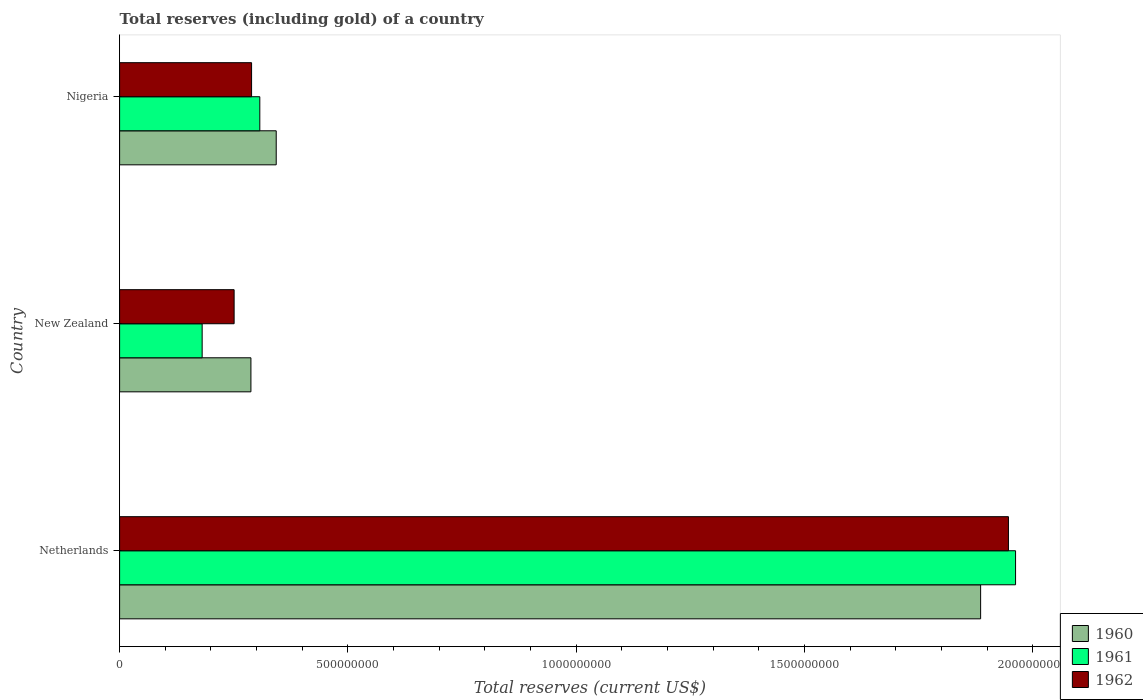How many different coloured bars are there?
Offer a terse response. 3. Are the number of bars per tick equal to the number of legend labels?
Keep it short and to the point. Yes. How many bars are there on the 3rd tick from the top?
Provide a short and direct response. 3. How many bars are there on the 3rd tick from the bottom?
Your answer should be very brief. 3. What is the label of the 1st group of bars from the top?
Offer a very short reply. Nigeria. What is the total reserves (including gold) in 1962 in Netherlands?
Offer a terse response. 1.95e+09. Across all countries, what is the maximum total reserves (including gold) in 1961?
Keep it short and to the point. 1.96e+09. Across all countries, what is the minimum total reserves (including gold) in 1962?
Give a very brief answer. 2.51e+08. In which country was the total reserves (including gold) in 1961 minimum?
Offer a very short reply. New Zealand. What is the total total reserves (including gold) in 1962 in the graph?
Provide a succinct answer. 2.49e+09. What is the difference between the total reserves (including gold) in 1960 in New Zealand and that in Nigeria?
Provide a succinct answer. -5.54e+07. What is the difference between the total reserves (including gold) in 1962 in Netherlands and the total reserves (including gold) in 1961 in Nigeria?
Provide a succinct answer. 1.64e+09. What is the average total reserves (including gold) in 1961 per country?
Your response must be concise. 8.17e+08. What is the difference between the total reserves (including gold) in 1960 and total reserves (including gold) in 1962 in Netherlands?
Provide a short and direct response. -6.09e+07. In how many countries, is the total reserves (including gold) in 1960 greater than 1500000000 US$?
Offer a terse response. 1. What is the ratio of the total reserves (including gold) in 1960 in New Zealand to that in Nigeria?
Your answer should be very brief. 0.84. Is the total reserves (including gold) in 1961 in New Zealand less than that in Nigeria?
Your answer should be compact. Yes. What is the difference between the highest and the second highest total reserves (including gold) in 1960?
Offer a very short reply. 1.54e+09. What is the difference between the highest and the lowest total reserves (including gold) in 1960?
Offer a terse response. 1.60e+09. In how many countries, is the total reserves (including gold) in 1960 greater than the average total reserves (including gold) in 1960 taken over all countries?
Offer a terse response. 1. Is the sum of the total reserves (including gold) in 1962 in Netherlands and New Zealand greater than the maximum total reserves (including gold) in 1961 across all countries?
Your answer should be compact. Yes. What does the 3rd bar from the top in Nigeria represents?
Keep it short and to the point. 1960. What does the 2nd bar from the bottom in New Zealand represents?
Keep it short and to the point. 1961. Is it the case that in every country, the sum of the total reserves (including gold) in 1961 and total reserves (including gold) in 1960 is greater than the total reserves (including gold) in 1962?
Ensure brevity in your answer.  Yes. How many bars are there?
Provide a short and direct response. 9. Does the graph contain grids?
Give a very brief answer. No. How are the legend labels stacked?
Provide a short and direct response. Vertical. What is the title of the graph?
Give a very brief answer. Total reserves (including gold) of a country. What is the label or title of the X-axis?
Offer a terse response. Total reserves (current US$). What is the label or title of the Y-axis?
Provide a short and direct response. Country. What is the Total reserves (current US$) of 1960 in Netherlands?
Offer a terse response. 1.89e+09. What is the Total reserves (current US$) in 1961 in Netherlands?
Your answer should be very brief. 1.96e+09. What is the Total reserves (current US$) of 1962 in Netherlands?
Give a very brief answer. 1.95e+09. What is the Total reserves (current US$) in 1960 in New Zealand?
Your answer should be compact. 2.88e+08. What is the Total reserves (current US$) of 1961 in New Zealand?
Your response must be concise. 1.81e+08. What is the Total reserves (current US$) of 1962 in New Zealand?
Your response must be concise. 2.51e+08. What is the Total reserves (current US$) of 1960 in Nigeria?
Offer a terse response. 3.43e+08. What is the Total reserves (current US$) of 1961 in Nigeria?
Give a very brief answer. 3.07e+08. What is the Total reserves (current US$) in 1962 in Nigeria?
Give a very brief answer. 2.89e+08. Across all countries, what is the maximum Total reserves (current US$) of 1960?
Your answer should be very brief. 1.89e+09. Across all countries, what is the maximum Total reserves (current US$) of 1961?
Your response must be concise. 1.96e+09. Across all countries, what is the maximum Total reserves (current US$) in 1962?
Your answer should be compact. 1.95e+09. Across all countries, what is the minimum Total reserves (current US$) of 1960?
Your response must be concise. 2.88e+08. Across all countries, what is the minimum Total reserves (current US$) of 1961?
Give a very brief answer. 1.81e+08. Across all countries, what is the minimum Total reserves (current US$) in 1962?
Make the answer very short. 2.51e+08. What is the total Total reserves (current US$) in 1960 in the graph?
Provide a succinct answer. 2.52e+09. What is the total Total reserves (current US$) in 1961 in the graph?
Offer a terse response. 2.45e+09. What is the total Total reserves (current US$) of 1962 in the graph?
Keep it short and to the point. 2.49e+09. What is the difference between the Total reserves (current US$) in 1960 in Netherlands and that in New Zealand?
Provide a short and direct response. 1.60e+09. What is the difference between the Total reserves (current US$) of 1961 in Netherlands and that in New Zealand?
Give a very brief answer. 1.78e+09. What is the difference between the Total reserves (current US$) of 1962 in Netherlands and that in New Zealand?
Offer a terse response. 1.70e+09. What is the difference between the Total reserves (current US$) in 1960 in Netherlands and that in Nigeria?
Your response must be concise. 1.54e+09. What is the difference between the Total reserves (current US$) of 1961 in Netherlands and that in Nigeria?
Your response must be concise. 1.66e+09. What is the difference between the Total reserves (current US$) in 1962 in Netherlands and that in Nigeria?
Provide a succinct answer. 1.66e+09. What is the difference between the Total reserves (current US$) in 1960 in New Zealand and that in Nigeria?
Your answer should be very brief. -5.54e+07. What is the difference between the Total reserves (current US$) in 1961 in New Zealand and that in Nigeria?
Ensure brevity in your answer.  -1.26e+08. What is the difference between the Total reserves (current US$) in 1962 in New Zealand and that in Nigeria?
Give a very brief answer. -3.82e+07. What is the difference between the Total reserves (current US$) in 1960 in Netherlands and the Total reserves (current US$) in 1961 in New Zealand?
Keep it short and to the point. 1.70e+09. What is the difference between the Total reserves (current US$) in 1960 in Netherlands and the Total reserves (current US$) in 1962 in New Zealand?
Provide a succinct answer. 1.63e+09. What is the difference between the Total reserves (current US$) in 1961 in Netherlands and the Total reserves (current US$) in 1962 in New Zealand?
Offer a terse response. 1.71e+09. What is the difference between the Total reserves (current US$) in 1960 in Netherlands and the Total reserves (current US$) in 1961 in Nigeria?
Your answer should be compact. 1.58e+09. What is the difference between the Total reserves (current US$) in 1960 in Netherlands and the Total reserves (current US$) in 1962 in Nigeria?
Your answer should be compact. 1.60e+09. What is the difference between the Total reserves (current US$) in 1961 in Netherlands and the Total reserves (current US$) in 1962 in Nigeria?
Provide a short and direct response. 1.67e+09. What is the difference between the Total reserves (current US$) in 1960 in New Zealand and the Total reserves (current US$) in 1961 in Nigeria?
Provide a short and direct response. -1.95e+07. What is the difference between the Total reserves (current US$) in 1960 in New Zealand and the Total reserves (current US$) in 1962 in Nigeria?
Your response must be concise. -1.43e+06. What is the difference between the Total reserves (current US$) in 1961 in New Zealand and the Total reserves (current US$) in 1962 in Nigeria?
Your answer should be compact. -1.08e+08. What is the average Total reserves (current US$) in 1960 per country?
Keep it short and to the point. 8.39e+08. What is the average Total reserves (current US$) in 1961 per country?
Your answer should be very brief. 8.17e+08. What is the average Total reserves (current US$) in 1962 per country?
Keep it short and to the point. 8.29e+08. What is the difference between the Total reserves (current US$) in 1960 and Total reserves (current US$) in 1961 in Netherlands?
Provide a short and direct response. -7.65e+07. What is the difference between the Total reserves (current US$) in 1960 and Total reserves (current US$) in 1962 in Netherlands?
Keep it short and to the point. -6.09e+07. What is the difference between the Total reserves (current US$) in 1961 and Total reserves (current US$) in 1962 in Netherlands?
Your answer should be compact. 1.56e+07. What is the difference between the Total reserves (current US$) in 1960 and Total reserves (current US$) in 1961 in New Zealand?
Keep it short and to the point. 1.07e+08. What is the difference between the Total reserves (current US$) in 1960 and Total reserves (current US$) in 1962 in New Zealand?
Give a very brief answer. 3.68e+07. What is the difference between the Total reserves (current US$) of 1961 and Total reserves (current US$) of 1962 in New Zealand?
Provide a short and direct response. -7.00e+07. What is the difference between the Total reserves (current US$) of 1960 and Total reserves (current US$) of 1961 in Nigeria?
Provide a succinct answer. 3.59e+07. What is the difference between the Total reserves (current US$) of 1960 and Total reserves (current US$) of 1962 in Nigeria?
Provide a succinct answer. 5.40e+07. What is the difference between the Total reserves (current US$) in 1961 and Total reserves (current US$) in 1962 in Nigeria?
Offer a terse response. 1.80e+07. What is the ratio of the Total reserves (current US$) in 1960 in Netherlands to that in New Zealand?
Provide a succinct answer. 6.56. What is the ratio of the Total reserves (current US$) in 1961 in Netherlands to that in New Zealand?
Provide a succinct answer. 10.85. What is the ratio of the Total reserves (current US$) of 1962 in Netherlands to that in New Zealand?
Keep it short and to the point. 7.76. What is the ratio of the Total reserves (current US$) of 1960 in Netherlands to that in Nigeria?
Offer a very short reply. 5.5. What is the ratio of the Total reserves (current US$) in 1961 in Netherlands to that in Nigeria?
Your response must be concise. 6.39. What is the ratio of the Total reserves (current US$) of 1962 in Netherlands to that in Nigeria?
Your answer should be very brief. 6.74. What is the ratio of the Total reserves (current US$) of 1960 in New Zealand to that in Nigeria?
Your response must be concise. 0.84. What is the ratio of the Total reserves (current US$) of 1961 in New Zealand to that in Nigeria?
Provide a short and direct response. 0.59. What is the ratio of the Total reserves (current US$) in 1962 in New Zealand to that in Nigeria?
Your answer should be compact. 0.87. What is the difference between the highest and the second highest Total reserves (current US$) in 1960?
Provide a short and direct response. 1.54e+09. What is the difference between the highest and the second highest Total reserves (current US$) of 1961?
Provide a short and direct response. 1.66e+09. What is the difference between the highest and the second highest Total reserves (current US$) of 1962?
Give a very brief answer. 1.66e+09. What is the difference between the highest and the lowest Total reserves (current US$) of 1960?
Give a very brief answer. 1.60e+09. What is the difference between the highest and the lowest Total reserves (current US$) in 1961?
Provide a short and direct response. 1.78e+09. What is the difference between the highest and the lowest Total reserves (current US$) of 1962?
Keep it short and to the point. 1.70e+09. 